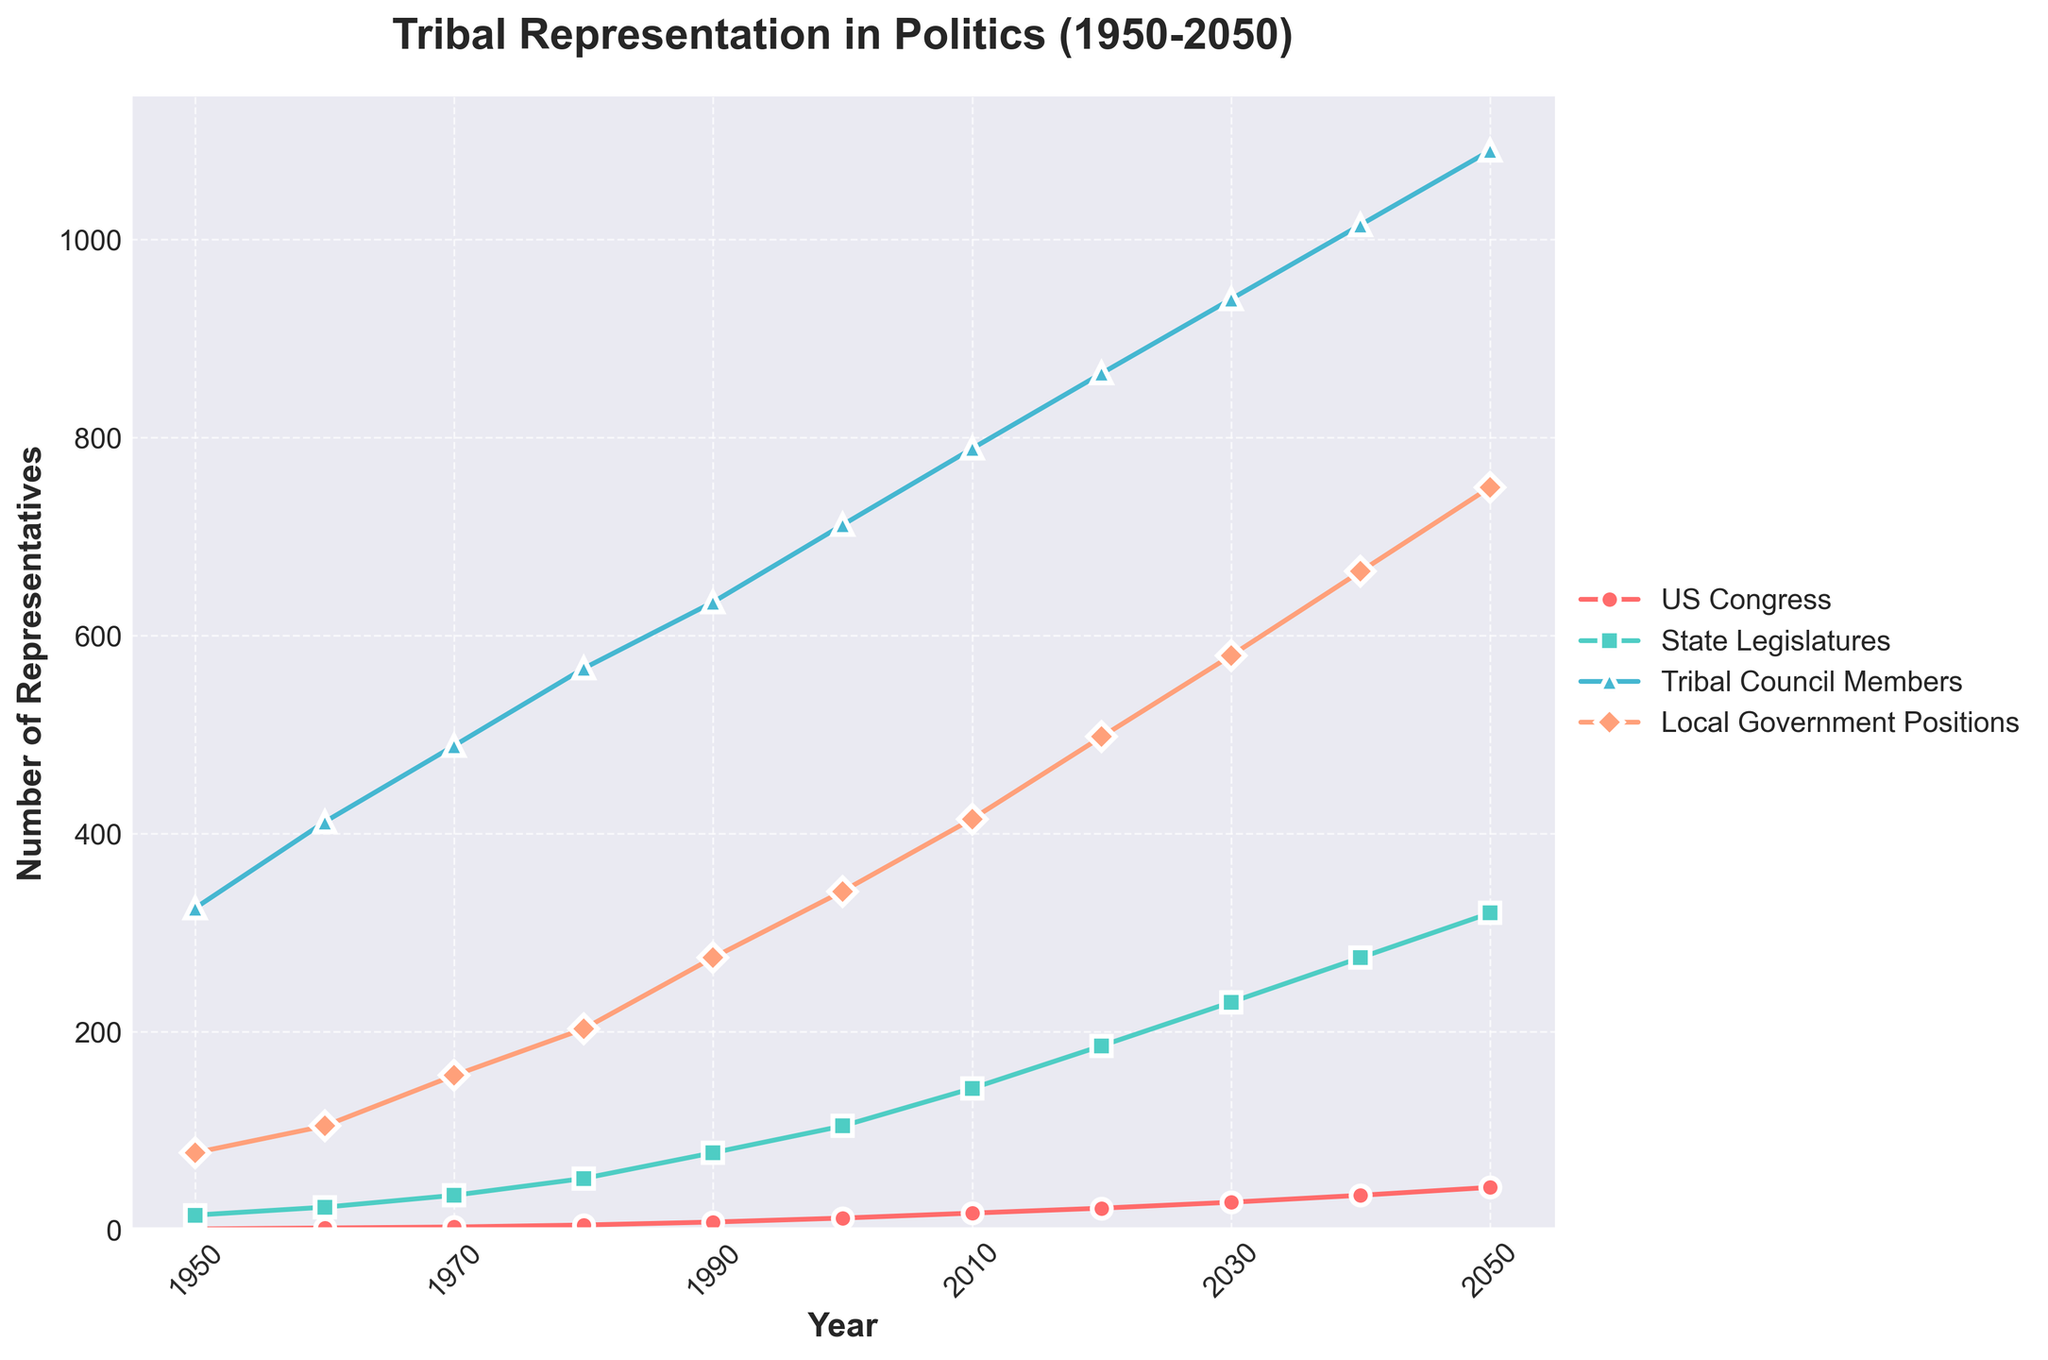Which year is projected to have the highest number of tribal members in US Congress? By observing the trend line for US Congress, we see that the highest value is in the year 2050.
Answer: 2050 Between which decades does the number of representatives in State Legislatures show the highest increase? Look at the State Legislatures trend line. The biggest jump appears between 2020 and 2030.
Answer: 2020 and 2030 What is the difference in the number of Tribal Council Members between 2020 and 2050? Subtract the number of Tribal Council Members in 2020 (865) from that in 2050 (1090). 1090 - 865 = 225
Answer: 225 How many total representatives are there in Local Government Positions in 2000 and 2010 combined? Add the representatives in Local Government Positions for 2000 (342) and for 2010 (415). 342 + 415 = 757
Answer: 757 Which group has the smallest number of representatives in 1980? Observe the trend lines for 1980. The smallest value is for Local Government Positions (203).
Answer: Local Government Positions Is the number of representatives in State Legislatures ever greater than Tribal Council Members? Compare the two trend lines. The number in State Legislatures is always lower than in Tribal Council Members throughout the period.
Answer: No How many total tribal representatives are there across all categories in 2030? Sum the values for all categories in the year 2030 (US Congress: 28, State Legislatures: 230, Tribal Council Members: 940, Local Government Positions: 580). 28 + 230 + 940 + 580 = 1778
Answer: 1778 How many total tribal members were represented in politics in 1950 across all categories? Sum the values for all categories in the year 1950 (US Congress: 1, State Legislatures: 15, Tribal Council Members: 325, Local Government Positions: 78). 1 + 15 + 325 + 78 = 419
Answer: 419 Which data category shows the most consistent increase over time? Observe the trend lines for consistency. All categories show consistent growth, but Tribal Council Members shows a relatively smoother and more consistent increase.
Answer: Tribal Council Members 